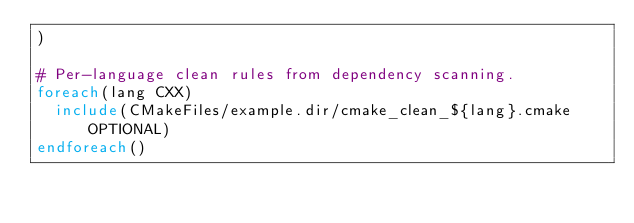<code> <loc_0><loc_0><loc_500><loc_500><_CMake_>)

# Per-language clean rules from dependency scanning.
foreach(lang CXX)
  include(CMakeFiles/example.dir/cmake_clean_${lang}.cmake OPTIONAL)
endforeach()
</code> 